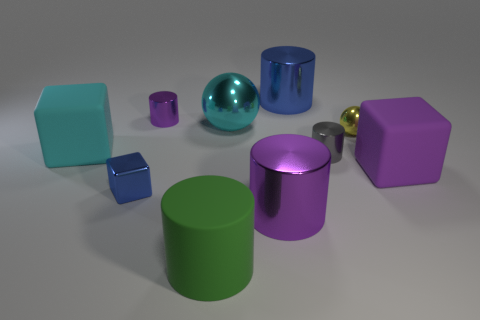Subtract 2 cylinders. How many cylinders are left? 3 Subtract all large green rubber cylinders. How many cylinders are left? 4 Subtract all green cylinders. How many cylinders are left? 4 Subtract all brown cylinders. Subtract all brown blocks. How many cylinders are left? 5 Subtract all balls. How many objects are left? 8 Add 2 large matte cylinders. How many large matte cylinders are left? 3 Add 8 small red balls. How many small red balls exist? 8 Subtract 0 yellow cubes. How many objects are left? 10 Subtract all green matte cylinders. Subtract all big blue metal cylinders. How many objects are left? 8 